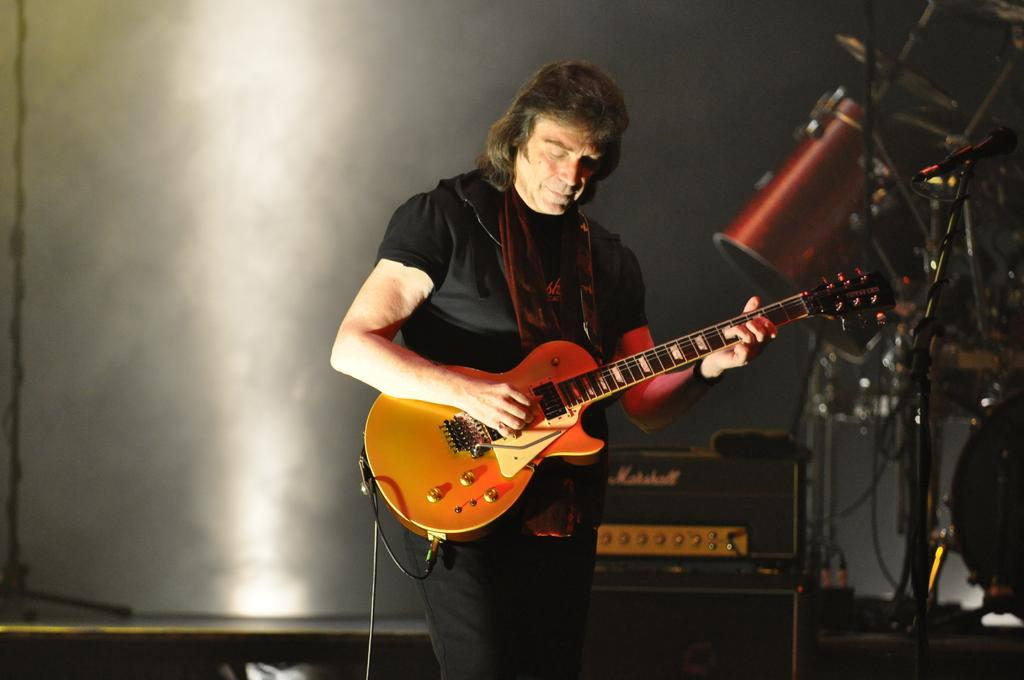Who is the main subject in the image? There is a man in the image. What is the man doing in the image? The man is playing a guitar. Are there any other musical instruments visible in the image? Yes, there are other musical instruments visible in the image. What type of bird can be seen flying over the boats in the image? There are no boats or birds present in the image; it features a man playing a guitar and other musical instruments. 